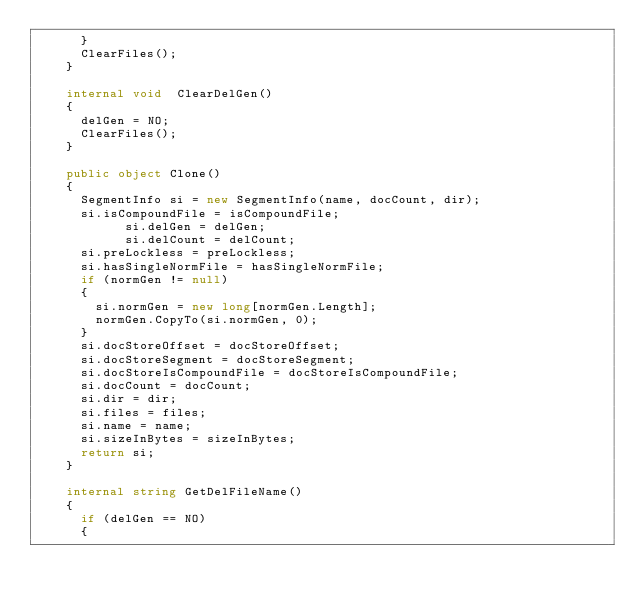Convert code to text. <code><loc_0><loc_0><loc_500><loc_500><_C#_>			}
			ClearFiles();
		}
		
		internal void  ClearDelGen()
		{
			delGen = NO;
			ClearFiles();
		}
		
		public object Clone()
		{
			SegmentInfo si = new SegmentInfo(name, docCount, dir);
			si.isCompoundFile = isCompoundFile;
            si.delGen = delGen;
            si.delCount = delCount;
			si.preLockless = preLockless;
			si.hasSingleNormFile = hasSingleNormFile;
			if (normGen != null)
			{
				si.normGen = new long[normGen.Length];
				normGen.CopyTo(si.normGen, 0);
			}
			si.docStoreOffset = docStoreOffset;
			si.docStoreSegment = docStoreSegment;
			si.docStoreIsCompoundFile = docStoreIsCompoundFile;
			si.docCount = docCount;
			si.dir = dir;
			si.files = files;
			si.name = name;
			si.sizeInBytes = sizeInBytes;
			return si;
		}
		
		internal string GetDelFileName()
		{
			if (delGen == NO)
			{</code> 